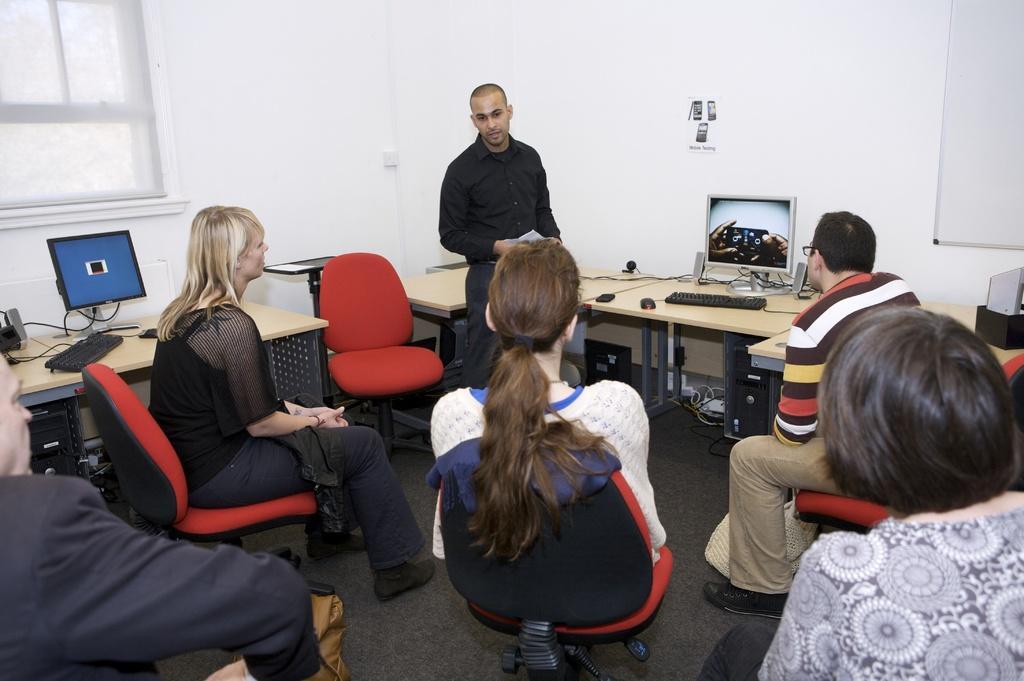Can you describe this image briefly? In the bottom of the image, few peoples are sat on the red chair. And the middle, a man is standing near the tables. Few items are placed on it. And background, we can see a white wall, sticker. On the right side, there is a whiteboard. On left side, we can see window. 